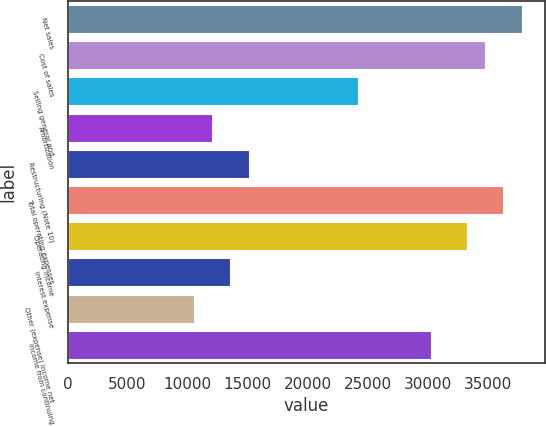<chart> <loc_0><loc_0><loc_500><loc_500><bar_chart><fcel>Net sales<fcel>Cost of sales<fcel>Selling general and<fcel>Amortization<fcel>Restructuring (Note 10)<fcel>Total operating expenses<fcel>Operating income<fcel>Interest expense<fcel>Other (expense) income net<fcel>Income from continuing<nl><fcel>37911.2<fcel>34878.3<fcel>24263.5<fcel>12132.2<fcel>15165<fcel>36394.8<fcel>33361.9<fcel>13648.6<fcel>10615.8<fcel>30329.1<nl></chart> 